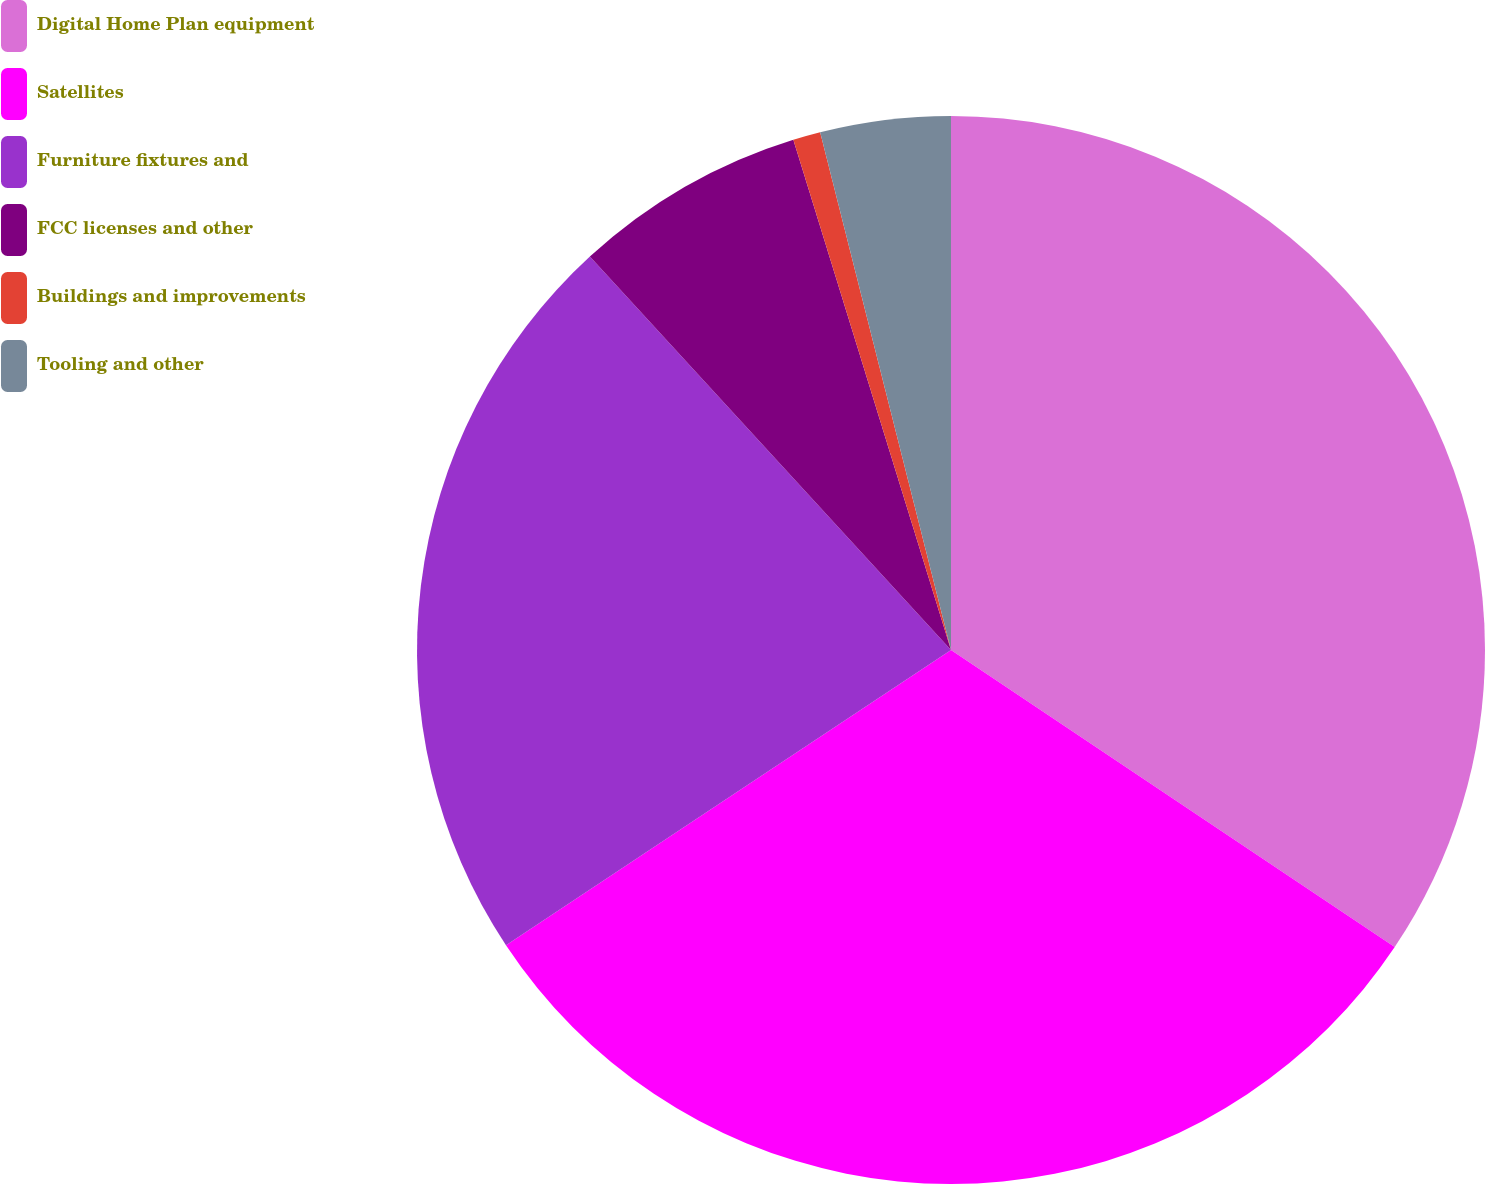Convert chart. <chart><loc_0><loc_0><loc_500><loc_500><pie_chart><fcel>Digital Home Plan equipment<fcel>Satellites<fcel>Furniture fixtures and<fcel>FCC licenses and other<fcel>Buildings and improvements<fcel>Tooling and other<nl><fcel>34.39%<fcel>31.29%<fcel>22.5%<fcel>7.05%<fcel>0.83%<fcel>3.94%<nl></chart> 